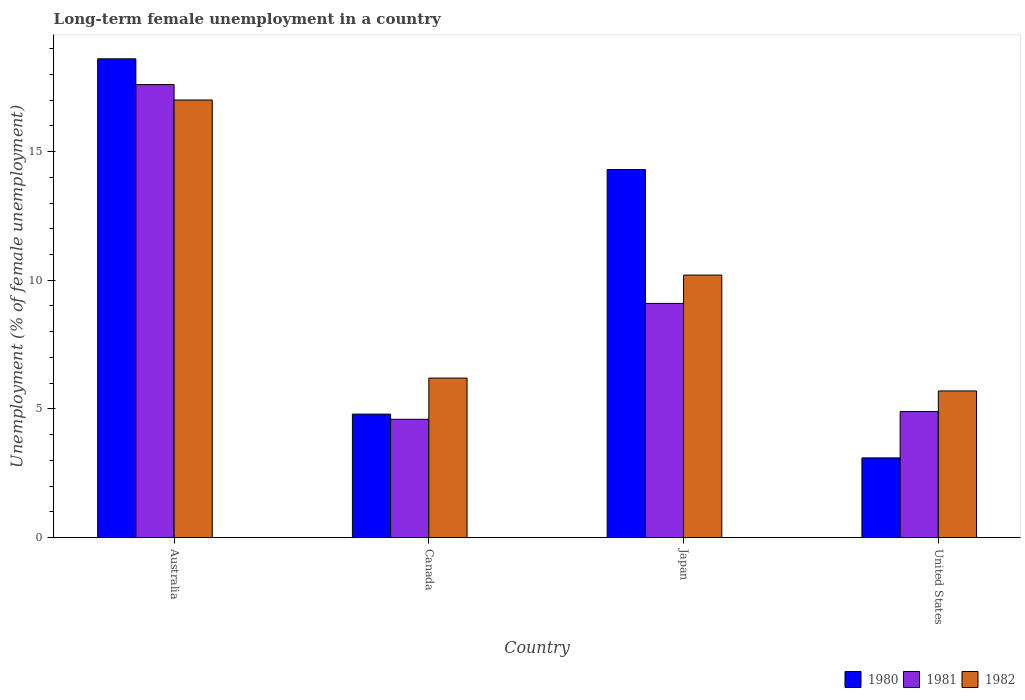How many different coloured bars are there?
Give a very brief answer. 3. Are the number of bars per tick equal to the number of legend labels?
Your response must be concise. Yes. What is the label of the 3rd group of bars from the left?
Keep it short and to the point. Japan. In how many cases, is the number of bars for a given country not equal to the number of legend labels?
Keep it short and to the point. 0. What is the percentage of long-term unemployed female population in 1980 in United States?
Keep it short and to the point. 3.1. Across all countries, what is the maximum percentage of long-term unemployed female population in 1980?
Offer a terse response. 18.6. Across all countries, what is the minimum percentage of long-term unemployed female population in 1980?
Offer a terse response. 3.1. In which country was the percentage of long-term unemployed female population in 1982 maximum?
Your response must be concise. Australia. In which country was the percentage of long-term unemployed female population in 1982 minimum?
Make the answer very short. United States. What is the total percentage of long-term unemployed female population in 1981 in the graph?
Your answer should be very brief. 36.2. What is the difference between the percentage of long-term unemployed female population in 1980 in Canada and that in Japan?
Keep it short and to the point. -9.5. What is the difference between the percentage of long-term unemployed female population in 1982 in Australia and the percentage of long-term unemployed female population in 1980 in Canada?
Give a very brief answer. 12.2. What is the average percentage of long-term unemployed female population in 1982 per country?
Offer a very short reply. 9.77. What is the difference between the percentage of long-term unemployed female population of/in 1982 and percentage of long-term unemployed female population of/in 1981 in Australia?
Keep it short and to the point. -0.6. In how many countries, is the percentage of long-term unemployed female population in 1980 greater than 12 %?
Ensure brevity in your answer.  2. What is the ratio of the percentage of long-term unemployed female population in 1980 in Australia to that in Japan?
Your answer should be compact. 1.3. Is the percentage of long-term unemployed female population in 1982 in Canada less than that in Japan?
Your answer should be compact. Yes. Is the difference between the percentage of long-term unemployed female population in 1982 in Australia and Japan greater than the difference between the percentage of long-term unemployed female population in 1981 in Australia and Japan?
Your answer should be compact. No. What is the difference between the highest and the second highest percentage of long-term unemployed female population in 1982?
Give a very brief answer. 6.8. What is the difference between the highest and the lowest percentage of long-term unemployed female population in 1981?
Keep it short and to the point. 13. In how many countries, is the percentage of long-term unemployed female population in 1982 greater than the average percentage of long-term unemployed female population in 1982 taken over all countries?
Keep it short and to the point. 2. Is the sum of the percentage of long-term unemployed female population in 1981 in Australia and Canada greater than the maximum percentage of long-term unemployed female population in 1982 across all countries?
Your answer should be compact. Yes. What does the 3rd bar from the left in United States represents?
Your response must be concise. 1982. How many countries are there in the graph?
Provide a short and direct response. 4. Where does the legend appear in the graph?
Your response must be concise. Bottom right. How many legend labels are there?
Provide a short and direct response. 3. What is the title of the graph?
Offer a terse response. Long-term female unemployment in a country. What is the label or title of the X-axis?
Your response must be concise. Country. What is the label or title of the Y-axis?
Make the answer very short. Unemployment (% of female unemployment). What is the Unemployment (% of female unemployment) of 1980 in Australia?
Your answer should be very brief. 18.6. What is the Unemployment (% of female unemployment) in 1981 in Australia?
Provide a short and direct response. 17.6. What is the Unemployment (% of female unemployment) in 1980 in Canada?
Keep it short and to the point. 4.8. What is the Unemployment (% of female unemployment) of 1981 in Canada?
Keep it short and to the point. 4.6. What is the Unemployment (% of female unemployment) in 1982 in Canada?
Offer a very short reply. 6.2. What is the Unemployment (% of female unemployment) in 1980 in Japan?
Your answer should be compact. 14.3. What is the Unemployment (% of female unemployment) of 1981 in Japan?
Provide a short and direct response. 9.1. What is the Unemployment (% of female unemployment) in 1982 in Japan?
Your answer should be very brief. 10.2. What is the Unemployment (% of female unemployment) of 1980 in United States?
Provide a short and direct response. 3.1. What is the Unemployment (% of female unemployment) in 1981 in United States?
Your answer should be compact. 4.9. What is the Unemployment (% of female unemployment) in 1982 in United States?
Keep it short and to the point. 5.7. Across all countries, what is the maximum Unemployment (% of female unemployment) of 1980?
Your answer should be very brief. 18.6. Across all countries, what is the maximum Unemployment (% of female unemployment) of 1981?
Give a very brief answer. 17.6. Across all countries, what is the maximum Unemployment (% of female unemployment) of 1982?
Your answer should be compact. 17. Across all countries, what is the minimum Unemployment (% of female unemployment) of 1980?
Ensure brevity in your answer.  3.1. Across all countries, what is the minimum Unemployment (% of female unemployment) of 1981?
Provide a succinct answer. 4.6. Across all countries, what is the minimum Unemployment (% of female unemployment) in 1982?
Provide a short and direct response. 5.7. What is the total Unemployment (% of female unemployment) in 1980 in the graph?
Offer a terse response. 40.8. What is the total Unemployment (% of female unemployment) of 1981 in the graph?
Make the answer very short. 36.2. What is the total Unemployment (% of female unemployment) in 1982 in the graph?
Your response must be concise. 39.1. What is the difference between the Unemployment (% of female unemployment) of 1980 in Australia and that in Canada?
Your response must be concise. 13.8. What is the difference between the Unemployment (% of female unemployment) of 1981 in Australia and that in Canada?
Offer a very short reply. 13. What is the difference between the Unemployment (% of female unemployment) in 1982 in Australia and that in Canada?
Your answer should be compact. 10.8. What is the difference between the Unemployment (% of female unemployment) of 1980 in Australia and that in Japan?
Your response must be concise. 4.3. What is the difference between the Unemployment (% of female unemployment) of 1981 in Australia and that in Japan?
Offer a very short reply. 8.5. What is the difference between the Unemployment (% of female unemployment) of 1980 in Australia and that in United States?
Your response must be concise. 15.5. What is the difference between the Unemployment (% of female unemployment) of 1981 in Australia and that in United States?
Offer a terse response. 12.7. What is the difference between the Unemployment (% of female unemployment) in 1982 in Australia and that in United States?
Provide a short and direct response. 11.3. What is the difference between the Unemployment (% of female unemployment) of 1981 in Canada and that in Japan?
Your answer should be very brief. -4.5. What is the difference between the Unemployment (% of female unemployment) of 1980 in Canada and that in United States?
Provide a short and direct response. 1.7. What is the difference between the Unemployment (% of female unemployment) of 1982 in Canada and that in United States?
Provide a short and direct response. 0.5. What is the difference between the Unemployment (% of female unemployment) of 1980 in Japan and that in United States?
Offer a terse response. 11.2. What is the difference between the Unemployment (% of female unemployment) in 1982 in Japan and that in United States?
Give a very brief answer. 4.5. What is the difference between the Unemployment (% of female unemployment) in 1980 in Australia and the Unemployment (% of female unemployment) in 1981 in Canada?
Offer a terse response. 14. What is the difference between the Unemployment (% of female unemployment) of 1980 in Australia and the Unemployment (% of female unemployment) of 1982 in Canada?
Make the answer very short. 12.4. What is the difference between the Unemployment (% of female unemployment) in 1980 in Australia and the Unemployment (% of female unemployment) in 1982 in Japan?
Your answer should be very brief. 8.4. What is the difference between the Unemployment (% of female unemployment) in 1980 in Australia and the Unemployment (% of female unemployment) in 1982 in United States?
Offer a terse response. 12.9. What is the difference between the Unemployment (% of female unemployment) in 1980 in Canada and the Unemployment (% of female unemployment) in 1982 in Japan?
Your answer should be compact. -5.4. What is the difference between the Unemployment (% of female unemployment) in 1981 in Canada and the Unemployment (% of female unemployment) in 1982 in Japan?
Make the answer very short. -5.6. What is the difference between the Unemployment (% of female unemployment) in 1980 in Canada and the Unemployment (% of female unemployment) in 1981 in United States?
Your response must be concise. -0.1. What is the difference between the Unemployment (% of female unemployment) in 1981 in Japan and the Unemployment (% of female unemployment) in 1982 in United States?
Provide a short and direct response. 3.4. What is the average Unemployment (% of female unemployment) in 1981 per country?
Give a very brief answer. 9.05. What is the average Unemployment (% of female unemployment) in 1982 per country?
Offer a terse response. 9.78. What is the difference between the Unemployment (% of female unemployment) of 1980 and Unemployment (% of female unemployment) of 1982 in Australia?
Provide a succinct answer. 1.6. What is the difference between the Unemployment (% of female unemployment) in 1981 and Unemployment (% of female unemployment) in 1982 in Australia?
Offer a terse response. 0.6. What is the difference between the Unemployment (% of female unemployment) of 1980 and Unemployment (% of female unemployment) of 1982 in Canada?
Keep it short and to the point. -1.4. What is the difference between the Unemployment (% of female unemployment) of 1981 and Unemployment (% of female unemployment) of 1982 in Canada?
Your answer should be very brief. -1.6. What is the difference between the Unemployment (% of female unemployment) in 1980 and Unemployment (% of female unemployment) in 1981 in Japan?
Provide a succinct answer. 5.2. What is the difference between the Unemployment (% of female unemployment) of 1981 and Unemployment (% of female unemployment) of 1982 in Japan?
Provide a succinct answer. -1.1. What is the difference between the Unemployment (% of female unemployment) of 1981 and Unemployment (% of female unemployment) of 1982 in United States?
Provide a succinct answer. -0.8. What is the ratio of the Unemployment (% of female unemployment) in 1980 in Australia to that in Canada?
Keep it short and to the point. 3.88. What is the ratio of the Unemployment (% of female unemployment) in 1981 in Australia to that in Canada?
Your answer should be compact. 3.83. What is the ratio of the Unemployment (% of female unemployment) in 1982 in Australia to that in Canada?
Provide a succinct answer. 2.74. What is the ratio of the Unemployment (% of female unemployment) in 1980 in Australia to that in Japan?
Offer a terse response. 1.3. What is the ratio of the Unemployment (% of female unemployment) in 1981 in Australia to that in Japan?
Keep it short and to the point. 1.93. What is the ratio of the Unemployment (% of female unemployment) of 1980 in Australia to that in United States?
Provide a short and direct response. 6. What is the ratio of the Unemployment (% of female unemployment) in 1981 in Australia to that in United States?
Your response must be concise. 3.59. What is the ratio of the Unemployment (% of female unemployment) in 1982 in Australia to that in United States?
Ensure brevity in your answer.  2.98. What is the ratio of the Unemployment (% of female unemployment) of 1980 in Canada to that in Japan?
Your response must be concise. 0.34. What is the ratio of the Unemployment (% of female unemployment) in 1981 in Canada to that in Japan?
Offer a very short reply. 0.51. What is the ratio of the Unemployment (% of female unemployment) of 1982 in Canada to that in Japan?
Keep it short and to the point. 0.61. What is the ratio of the Unemployment (% of female unemployment) in 1980 in Canada to that in United States?
Your answer should be compact. 1.55. What is the ratio of the Unemployment (% of female unemployment) in 1981 in Canada to that in United States?
Ensure brevity in your answer.  0.94. What is the ratio of the Unemployment (% of female unemployment) in 1982 in Canada to that in United States?
Give a very brief answer. 1.09. What is the ratio of the Unemployment (% of female unemployment) of 1980 in Japan to that in United States?
Your response must be concise. 4.61. What is the ratio of the Unemployment (% of female unemployment) in 1981 in Japan to that in United States?
Provide a short and direct response. 1.86. What is the ratio of the Unemployment (% of female unemployment) in 1982 in Japan to that in United States?
Make the answer very short. 1.79. What is the difference between the highest and the second highest Unemployment (% of female unemployment) of 1981?
Make the answer very short. 8.5. What is the difference between the highest and the second highest Unemployment (% of female unemployment) in 1982?
Make the answer very short. 6.8. 